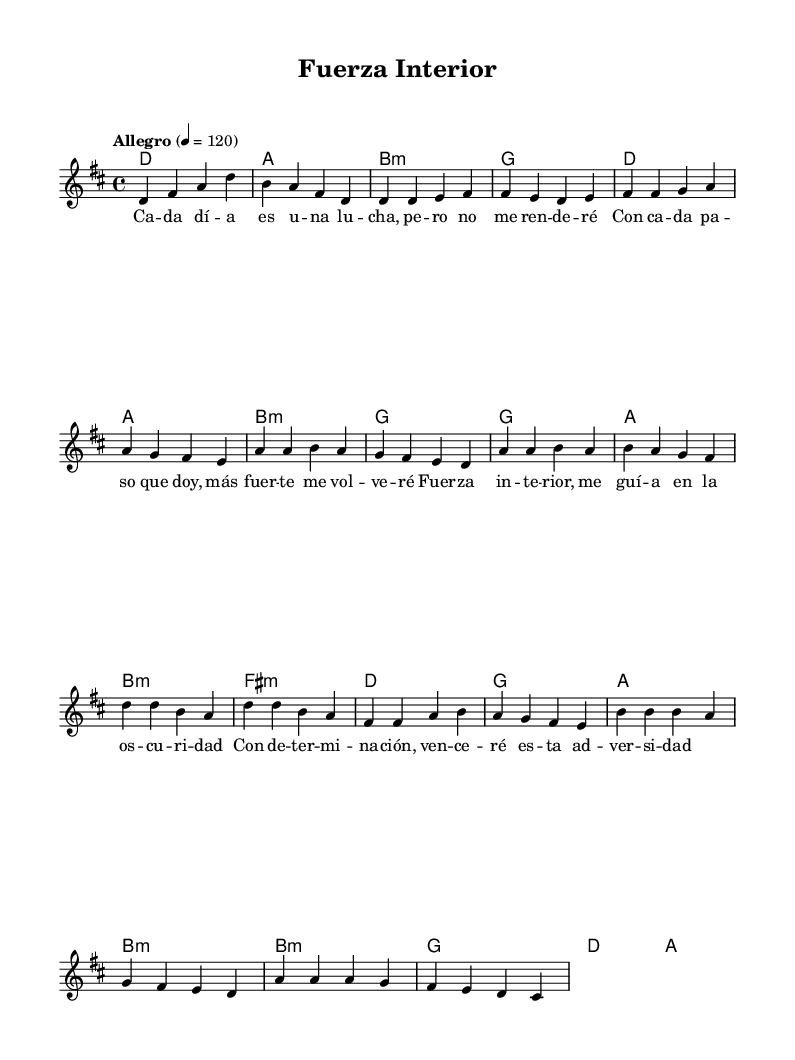What is the key signature of this music? The key signature is D major, which has two sharps (F# and C#). This can be determined from the initial measures which include the key signature marking, showing two sharps.
Answer: D major What is the time signature of this music? The time signature is 4/4, which indicates that there are four beats per measure, and the quarter note receives one beat. This is visible at the beginning of the score, just after the key signature.
Answer: 4/4 What is the tempo marking of this music? The tempo marking is Allegro, which indicates a fast pace. It can be found at the start of the sheet music, indicating the speed of performance.
Answer: Allegro How many sections are there in the song? There are five sections: Intro, Verse, Pre-Chorus, Chorus, and Bridge. By analyzing the structured layout of the music, we can see distinct parts marked by the lyrics and music phrases.
Answer: Five Which chord is played in the intro? The chord played in the intro is D major. This can be identified by looking at the chord names in the chord progression during the intro section of the music.
Answer: D major What is the main theme of the chorus? The main theme of the chorus is inner strength and overcoming adversity. By reading the lyrics provided in the chorus section, it highlights the determination to face challenges.
Answer: Inner strength What kind of musical feel is conveyed through the song? The song conveys a motivational and uplifting feel. This can be inferred from the tempo, key, and lyrical content focused on resilience and empowerment, characteristic of Latin pop music.
Answer: Motivational 